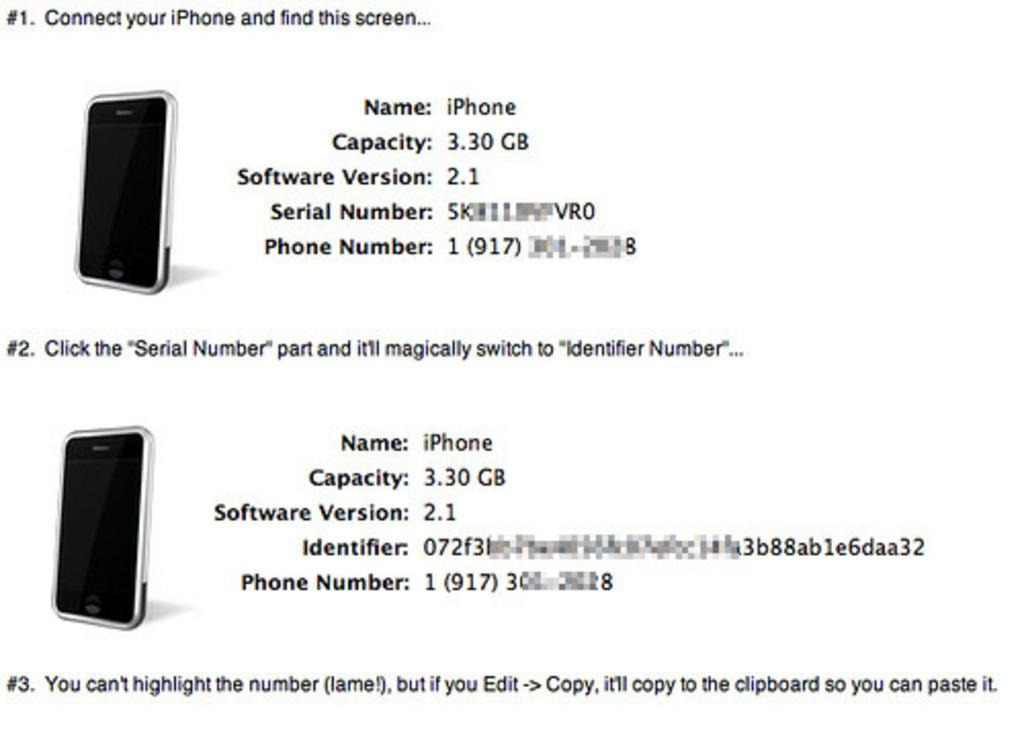<image>
Render a clear and concise summary of the photo. An information page about iPhone including the term Serial Number. 